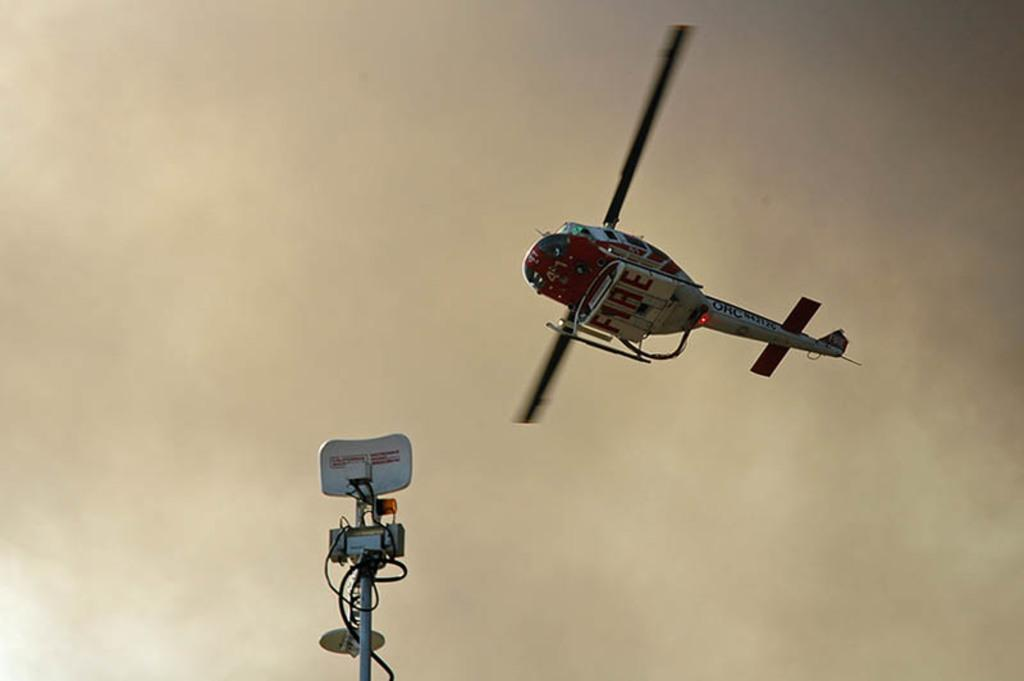<image>
Present a compact description of the photo's key features. A helicopter is flying overhead and the word FIRE can be seen on the bottom of the aircraft. 